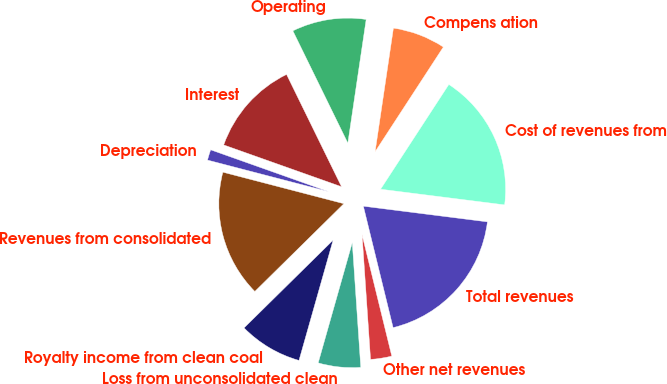<chart> <loc_0><loc_0><loc_500><loc_500><pie_chart><fcel>Revenues from consolidated<fcel>Royalty income from clean coal<fcel>Loss from unconsolidated clean<fcel>Other net revenues<fcel>Total revenues<fcel>Cost of revenues from<fcel>Compens ation<fcel>Operating<fcel>Interest<fcel>Depreciation<nl><fcel>16.44%<fcel>8.22%<fcel>5.48%<fcel>2.74%<fcel>19.18%<fcel>17.81%<fcel>6.85%<fcel>9.59%<fcel>12.33%<fcel>1.37%<nl></chart> 